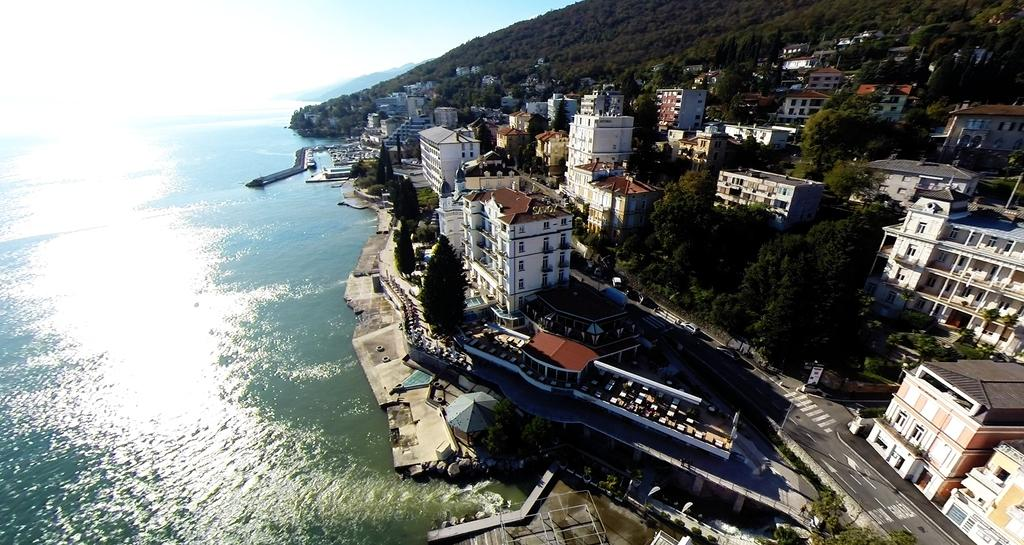What type of view is shown in the image? The image is an aerial view. What natural element can be seen in the image? There is water visible in the image. What man-made structures are present in the image? There are buildings and a road in the image. What type of vegetation is present in the image? Trees are present in the image. What geographical feature can be seen in the image? There are hills in the image. What is visible in the background of the image? The sky is visible in the background of the image. What government official can be seen in the image? There are no government officials present in the image. What type of spot is visible on the road in the image? There are no spots visible on the road in the image. 